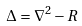Convert formula to latex. <formula><loc_0><loc_0><loc_500><loc_500>\Delta = \nabla ^ { 2 } - R</formula> 